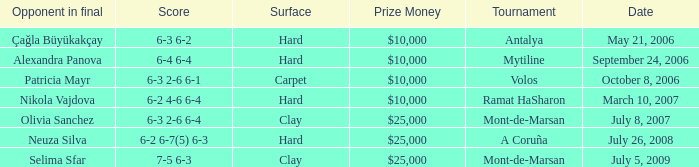What is the score of the hard court Ramat Hasharon tournament? 6-2 4-6 6-4. Parse the full table. {'header': ['Opponent in final', 'Score', 'Surface', 'Prize Money', 'Tournament', 'Date'], 'rows': [['Çağla Büyükakçay', '6-3 6-2', 'Hard', '$10,000', 'Antalya', 'May 21, 2006'], ['Alexandra Panova', '6-4 6-4', 'Hard', '$10,000', 'Mytiline', 'September 24, 2006'], ['Patricia Mayr', '6-3 2-6 6-1', 'Carpet', '$10,000', 'Volos', 'October 8, 2006'], ['Nikola Vajdova', '6-2 4-6 6-4', 'Hard', '$10,000', 'Ramat HaSharon', 'March 10, 2007'], ['Olivia Sanchez', '6-3 2-6 6-4', 'Clay', '$25,000', 'Mont-de-Marsan', 'July 8, 2007'], ['Neuza Silva', '6-2 6-7(5) 6-3', 'Hard', '$25,000', 'A Coruña', 'July 26, 2008'], ['Selima Sfar', '7-5 6-3', 'Clay', '$25,000', 'Mont-de-Marsan', 'July 5, 2009']]} 